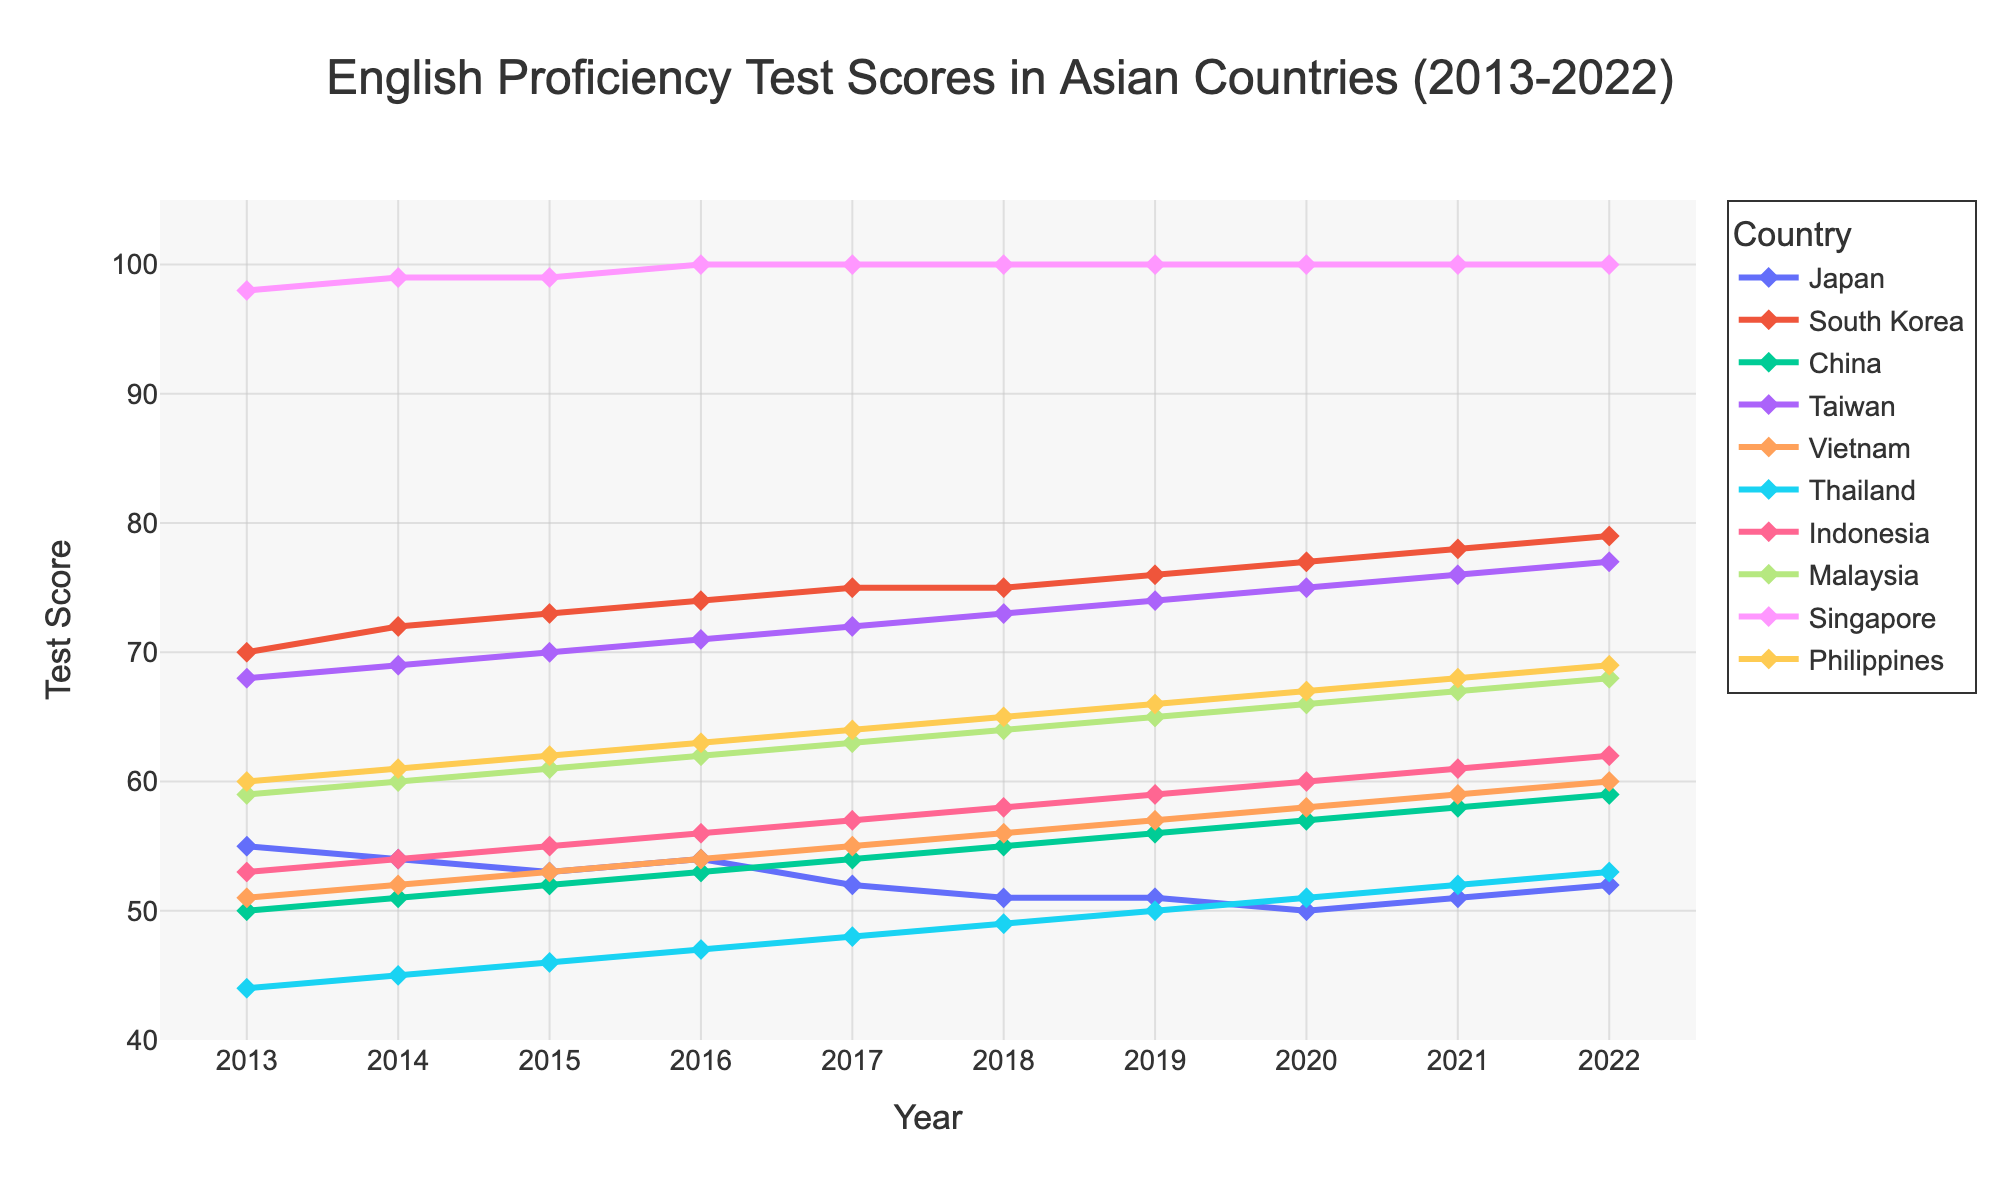What is the overall trend in English proficiency scores for Japan from 2013 to 2022? To determine the overall trend, examine the direction of the line representing Japan over time. The scores start at 55 in 2013 and generally decrease to 52 in 2022, with some fluctuations.
Answer: A slight decline Which country had the highest English proficiency score in 2022? Look at the scores for all countries in 2022. Singapore has a score of 100, which is the highest.
Answer: Singapore How does the trend in English proficiency scores for China compare to that of Vietnam? Observe the lines for China and Vietnam from 2013 to 2022. Both lines show a steady increase over the years, but China's scores started at 50 and increased to 59, while Vietnam's scores started at 51 and increased to 60. Both countries demonstrate a consistent upward trend.
Answer: Both show a steady increase What is the average English proficiency score for South Korea over the decade? Sum the scores for South Korea from 2013 to 2022 and divide by the number of years (10). (70 + 72 + 73 + 74 + 75 + 75 + 76 + 77 + 78 + 79) / 10 = 750 / 10 = 75
Answer: 75 Which country had the lowest English proficiency score in 2013? Compare the 2013 scores of all countries. Thailand has the lowest score at 44.
Answer: Thailand Between Malaysia and Indonesia, which country showed a greater increase in scores from 2013 to 2022? Find the difference in scores for both countries between 2013 and 2022. Malaysia's scores increased from 59 to 68 (an increase of 9), while Indonesia's scores increased from 53 to 62 (an increase of 9). Hence, both countries showed an equal increase.
Answer: Both equal Which country experienced the most consistent trend in English proficiency scores over the decade? Look for the country with the least fluctuation in scores. Singapore's scores stayed flat at 100 from 2015 onward, indicating the most consistent trend.
Answer: Singapore How many countries had an average score of 60 or above over the past decade? Calculate the average score for each country over the decade and count which ones are 60 or above. South Korea, Taiwan, Malaysia, Singapore, and the Philippines have average scores of 60 or above.
Answer: Five Compare Japan’s score in 2020 to its score in 2013. Did it improve, decline, or remain the same? Look at Japan’s scores for 2013 and 2020. In 2013, it was 55; in 2020, it was 50. The score declined.
Answer: Declined What is the difference in 2022 scores between the highest-scoring and the lowest-scoring countries? Identify the highest and lowest scores for 2022. Singapore has the highest at 100, and Japan has the lowest at 52. The difference is 100 - 52 = 48.
Answer: 48 